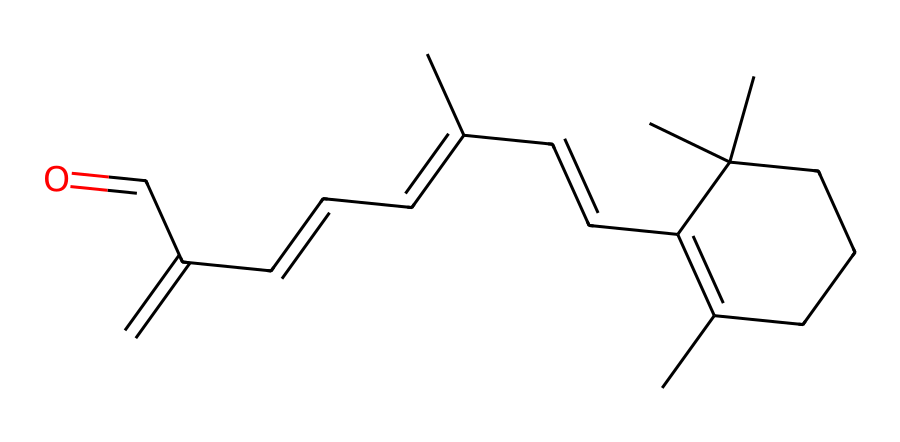How many carbon atoms are in this chemical structure? By examining the provided SMILES representation, we count the total number of 'C' characters, which indicates carbon atoms. In this case, there are 22 carbon atoms.
Answer: 22 What functional group is present in this chemical? Analyzing the structure, we see a carbonyl group indicated by the “C=O” part at the end of the chain. This suggests the presence of an aldehyde functional group, which is characteristic of retinol.
Answer: aldehyde How many rings are present in this chemical structure? The structure contains one ring indicated by the notation surrounding the first part in the SMILES representation. The presence of 'C1' and 'C' connecting back indicates a single cycloalkane ring.
Answer: 1 Is this chemical saturated or unsaturated? Looking at the presence of double bonds indicated by 'C=C' portions in the SMILES representation, we can conclude that it contains multiple double bonds, indicating that it is unsaturated.
Answer: unsaturated What is the common use of this chemical in cosmetics? Given the context of the chemical being retinol, it is primarily used in cosmetics for its anti-aging properties, helping to reduce wrinkles and improve skin texture.
Answer: anti-aging How would you classify the molecule type of this chemical? The presence of a hydrocarbon backbone with functional groups suggests this molecule can be classified as a retinoid, specifically an alcohol derivative. This classification is typical in cosmetic chemistry.
Answer: retinoid 